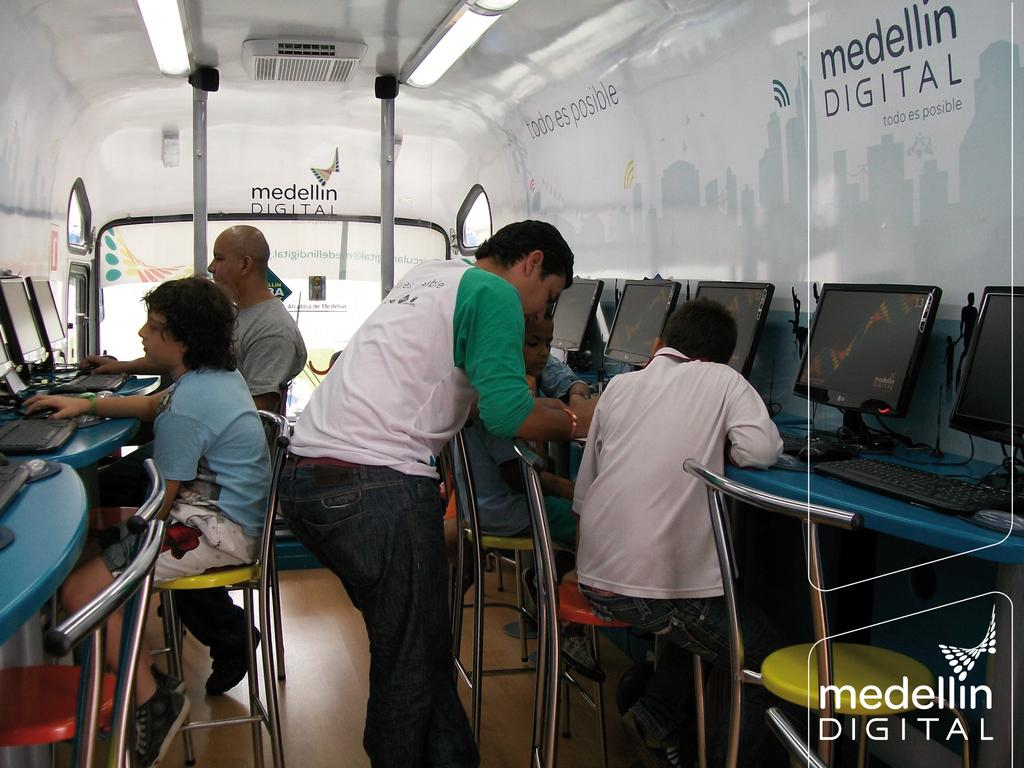How many people are in the image? There are 5 persons in the image. What are the positions of the majority of the people in the image? Four of the persons are sitting. What is the position of the remaining person in the image? One person is standing. What objects can be seen on the table in the image? There are computers on the table in the image. How many tickets are visible on the table in the image? There are no tickets visible on the table in the image. What type of paste is being used by the person standing in the image? There is no paste or any indication of its use in the image. 